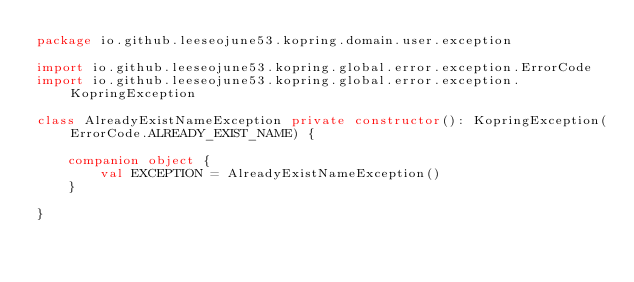Convert code to text. <code><loc_0><loc_0><loc_500><loc_500><_Kotlin_>package io.github.leeseojune53.kopring.domain.user.exception

import io.github.leeseojune53.kopring.global.error.exception.ErrorCode
import io.github.leeseojune53.kopring.global.error.exception.KopringException

class AlreadyExistNameException private constructor(): KopringException(ErrorCode.ALREADY_EXIST_NAME) {

    companion object {
        val EXCEPTION = AlreadyExistNameException()
    }

}</code> 